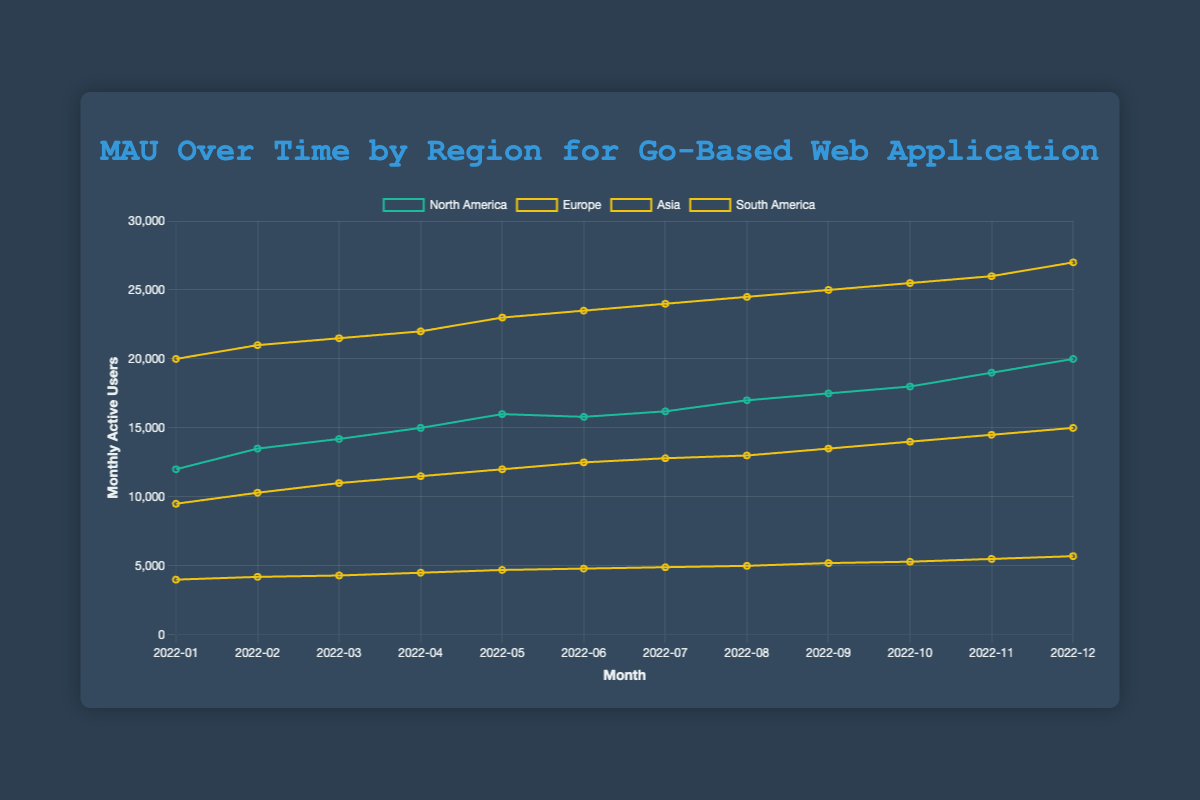Which region had the highest Monthly Active Users (MAU) in December 2022? By examining the end points of the lines, Asia shows the highest MAU in December 2022 compared to other regions.
Answer: Asia How did the MAU for Europe change from January 2022 to December 2022? From January 2022 to December 2022, the MAU for Europe increased from 9500 to 15000. The change is calculated by 15000 - 9500 = 5500.
Answer: Increased by 5500 Which region had a higher MAU in June 2022, North America or Europe? In June 2022, North America's MAU was 15800 and Europe's MAU was 12500. Since 15800 is greater than 12500, North America had a higher MAU.
Answer: North America What is the total number of MAUs for South America over the entire year of 2022? Summing the MAUs for each month in 2022 for South America gives: 4000 + 4200 + 4300 + 4500 + 4700 + 4800 + 4900 + 5000 + 5200 + 5300 + 5500 + 5700 = 62100.
Answer: 62100 Compare the trend of MAUs between North America and Asia from June 2022 to December 2022. From June 2022 to December 2022, North America's MAU line has a slight upward trend from 15800 to 20000, while Asia's MAU line has a steeper upward trend from 23500 to 27000. Asia's increase is more substantial compared to North America in the same period.
Answer: Asia shows a steeper increase What is the average MAU for Asia in 2022? Adding up the monthly MAUs for Asia in 2022: 20000 + 21000 + 21500 + 22000 + 23000 + 23500 + 24000 + 24500 + 25000 + 25500 + 26000 + 27000 = 283500. Dividing by 12 to find the average: 283500 / 12 = 23625.
Answer: 23625 Which month saw the largest increase in MAU for North America? To determine the largest monthly increase for North America, compare consecutive months: Feb: 13500-12000=1500, Mar: 14200-13500=700, Apr: 15000-14200=800, May: 16000-15000=1000, Jun: 15800-16000=-200, Jul: 16200-15800=400, Aug: 17000-16200=800, Sep: 17500-17000=500, Oct: 18000-17500=500, Nov: 19000-18000=1000, Dec: 20000-19000=1000. The largest increase is from Jan to Feb (1500).
Answer: February What's the difference in MAUs between the highest and lowest month for South America in 2022? For South America in 2022, the highest MAU is 5700 (December) and the lowest MAU is 4000 (January). The difference is 5700 - 4000 = 1700.
Answer: 1700 Which region had the most stable growth throughout 2022 based on the slope of the trend line? By visually inspecting the lines, Europe shows steady and incremental monthly increases without sharp spikes or dips, indicating the most stable growth.
Answer: Europe How many regions surpassed 15000 MAU by the end of December 2022? Examining the data points for December 2022, North America (20000), Europe (15000), and Asia (27000) surpassed 15000 MAU, while South America (5700) did not. So, 3 regions surpassed 15000 MAU.
Answer: 3 